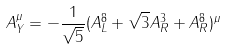<formula> <loc_0><loc_0><loc_500><loc_500>A _ { Y } ^ { \mu } = - \frac { 1 } { \sqrt { 5 } } ( A ^ { 8 } _ { L } + \sqrt { 3 } A ^ { 3 } _ { R } + A ^ { 8 } _ { R } ) ^ { \mu }</formula> 